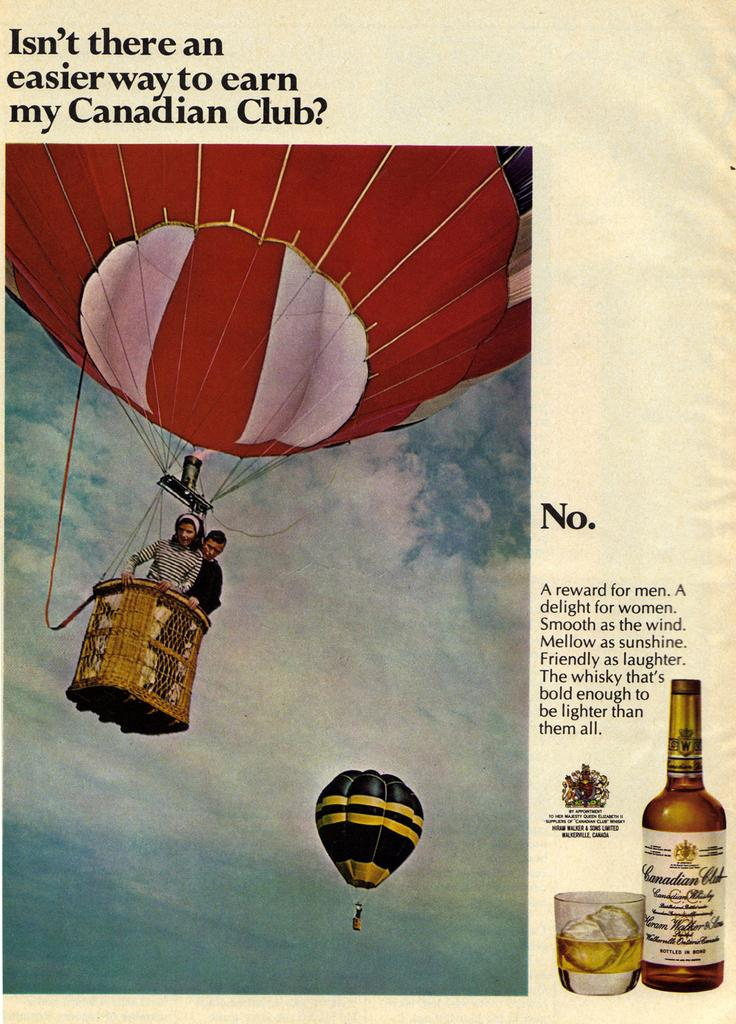<image>
Relay a brief, clear account of the picture shown. a sheet of paper about earning in a Canadian club 